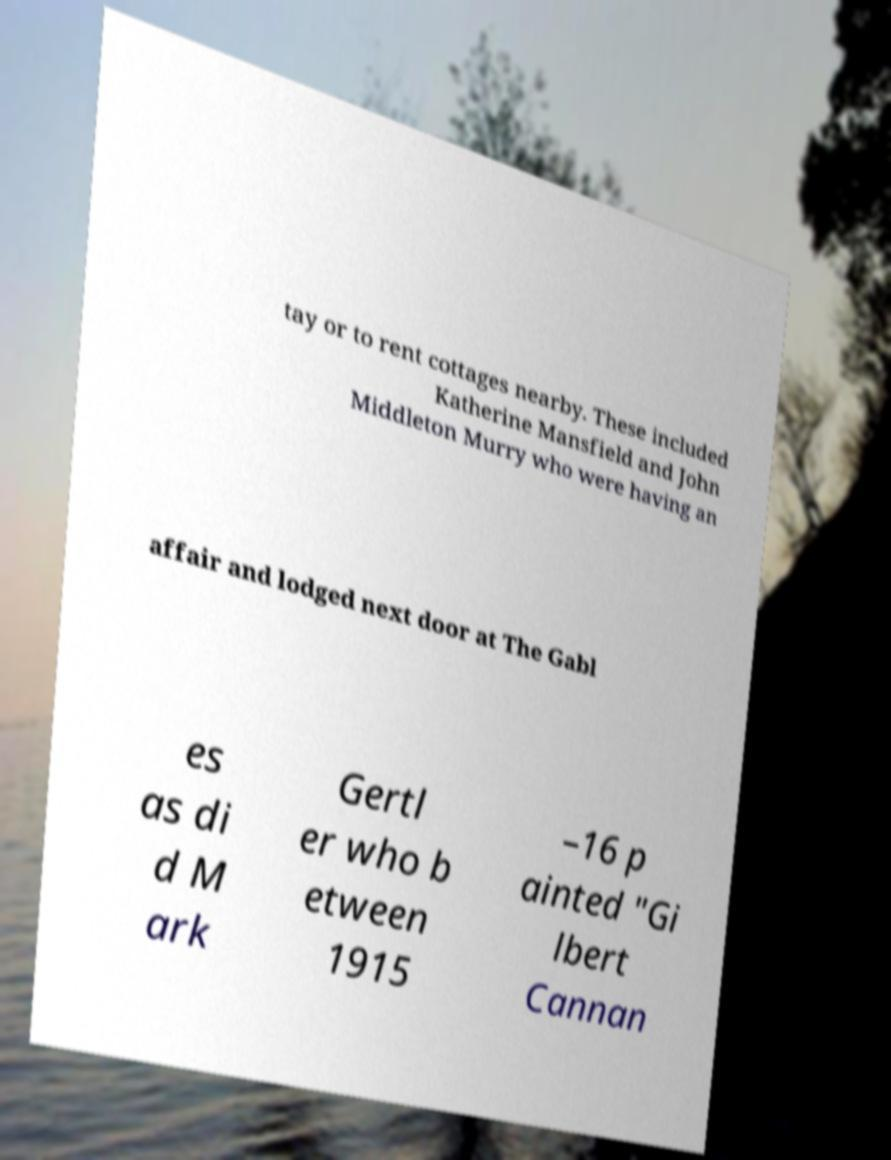Could you assist in decoding the text presented in this image and type it out clearly? tay or to rent cottages nearby. These included Katherine Mansfield and John Middleton Murry who were having an affair and lodged next door at The Gabl es as di d M ark Gertl er who b etween 1915 –16 p ainted "Gi lbert Cannan 